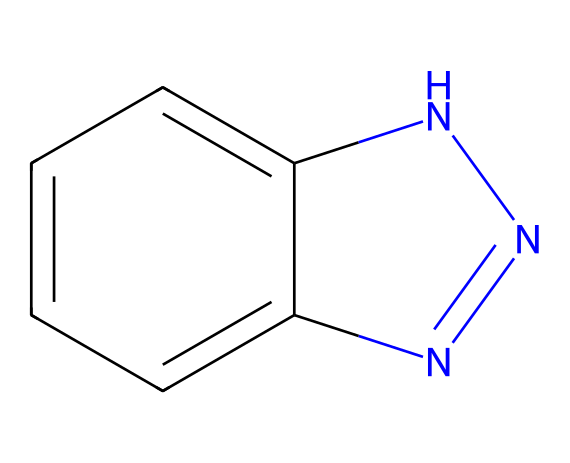What is the total number of nitrogen atoms in the structure? The SMILES representation includes two nitrogen atoms represented by 'n' and 'nH', contributing to a total of two nitrogen atoms.
Answer: 2 How many carbon atoms are visible in the chemical structure? The 'c' in the SMILES indicates aromatic carbon atoms; there are a total of six 'c' in the representation, indicating six carbon atoms in the structure.
Answer: 6 What type of ring structure is present in the chemical? The structure features a bicyclic system due to the connection between two rings; the first is an aromatic ring and the second is a five-membered ring containing nitrogen atoms.
Answer: bicyclic What functional group characterizes this chemical? This chemical contains an imide functional group, which is typically indicated by the presence of nitrogen atoms within a cyclic structure linked through carbonyl groups; the nitrogen in the rings aligns with this description.
Answer: imide Does this compound have any heteroatoms in the ring? Yes, the presence of nitrogen atoms as part of the rings indicates that there are heteroatoms in the structure, specifically two nitrogen atoms within the cyclic formation.
Answer: yes What distinguishes this imide from other similar compounds? This imide is characterized by its bicyclic structure in which the nitrogen atoms are part of aromatic and five-membered rings; this specific arrangement can influence its reactivity and properties compared to linear or saturated imides.
Answer: bicyclic structure 